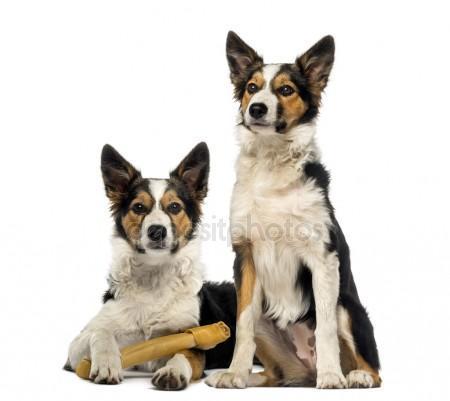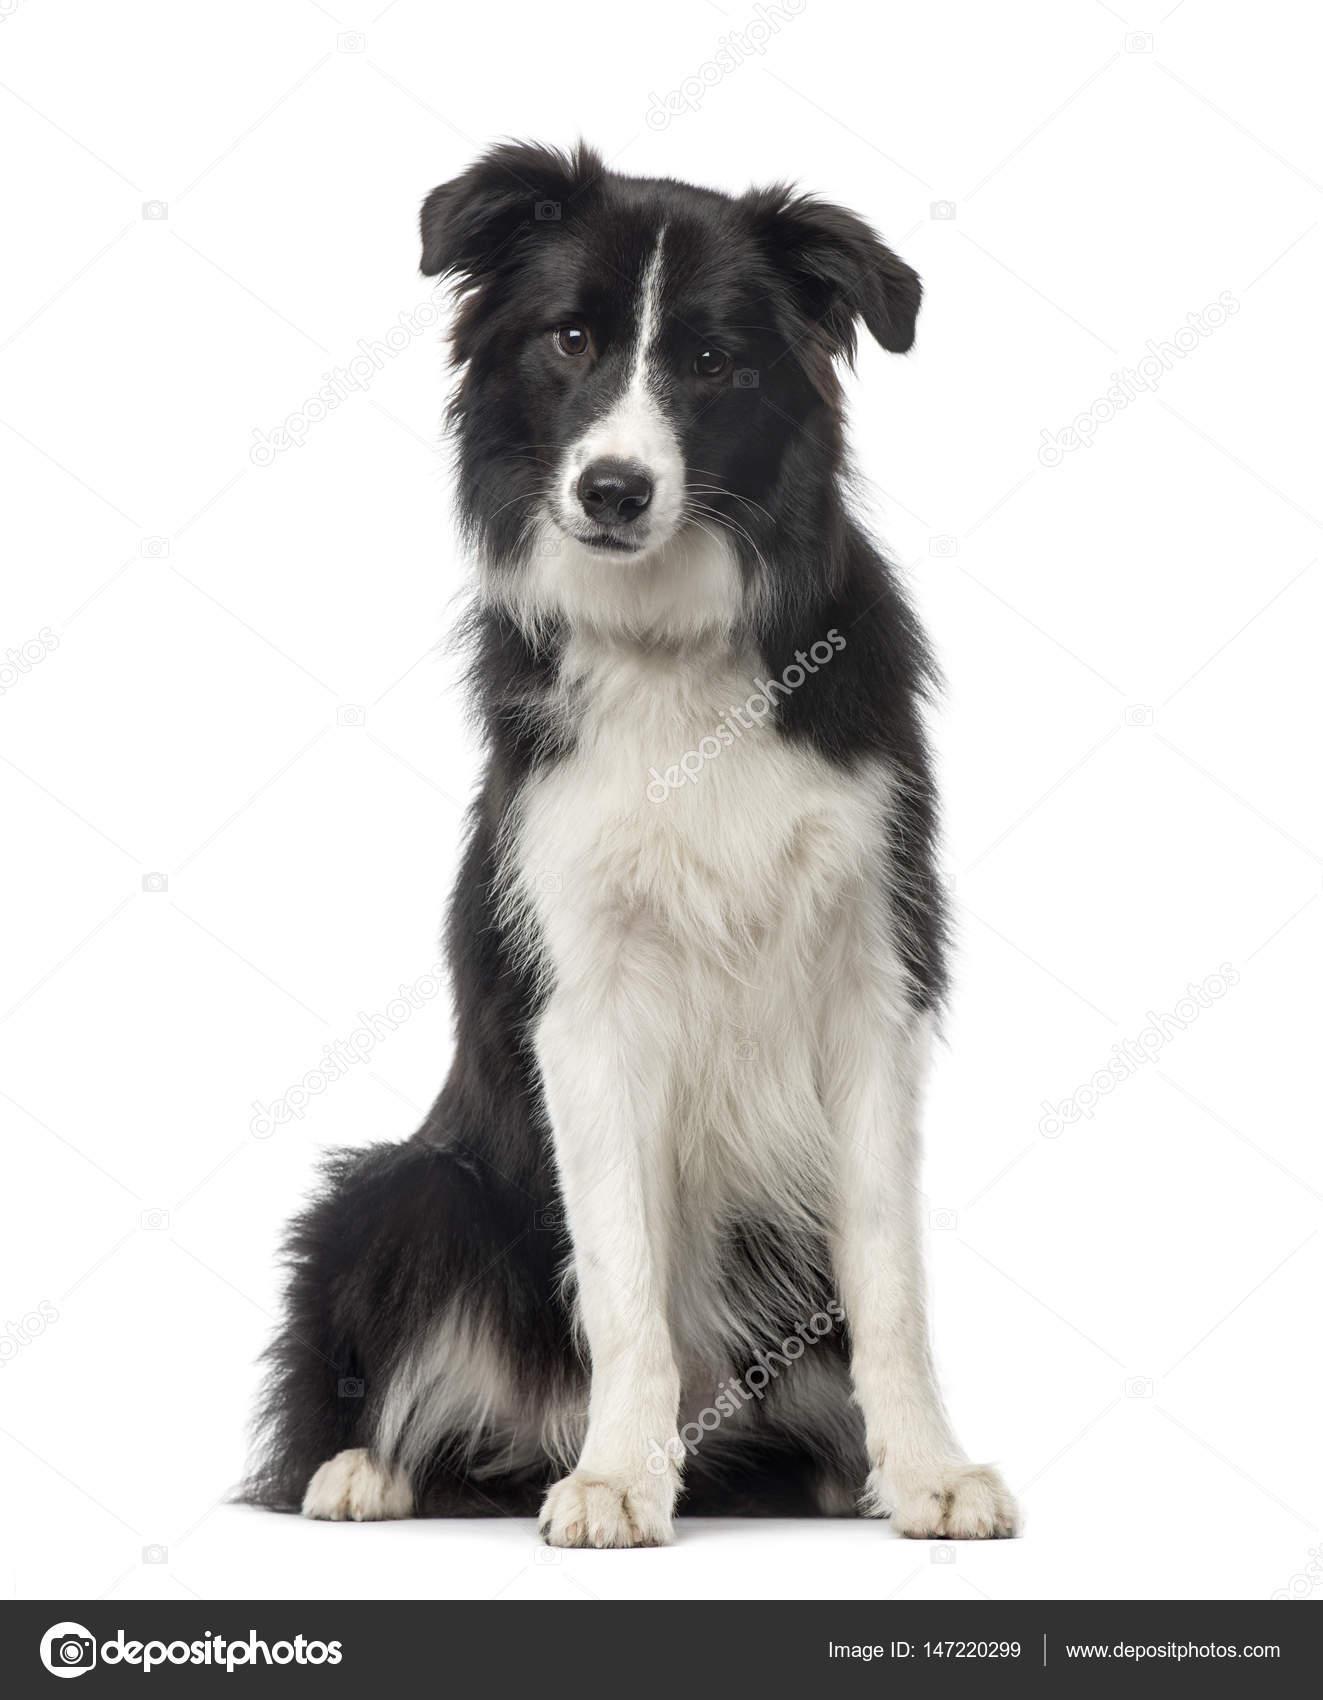The first image is the image on the left, the second image is the image on the right. Assess this claim about the two images: "There is exactly two dogs in the right image.". Correct or not? Answer yes or no. No. The first image is the image on the left, the second image is the image on the right. For the images shown, is this caption "The combined images contain three dogs, and in one image, a black-and-white dog sits upright and all alone." true? Answer yes or no. Yes. 